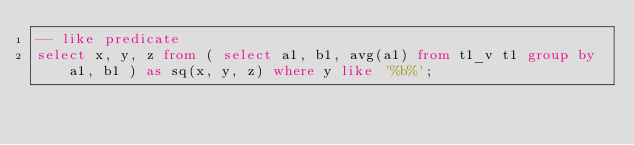<code> <loc_0><loc_0><loc_500><loc_500><_SQL_>-- like predicate
select x, y, z from ( select a1, b1, avg(a1) from t1_v t1 group by a1, b1 ) as sq(x, y, z) where y like '%b%';
</code> 